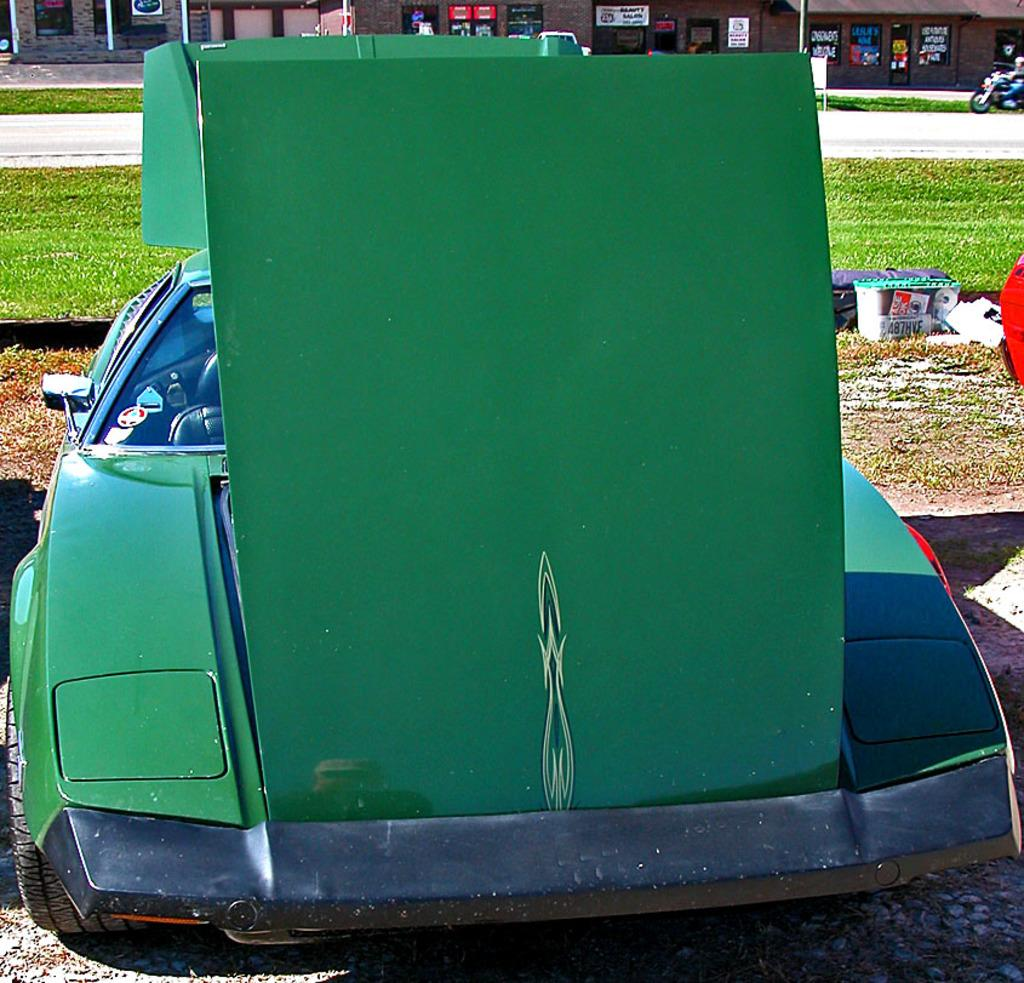What color is the vehicle in the image? The vehicle in the image is green. What type of vegetation can be seen in the image? There is grass visible in the image. What is covering the object in the image? There is a cover in the image. Can you describe the background of the image? In the background of the image, there is a road, a motorbike, houses, and poles. What type of pet can be seen in the image? There is no pet present in the image. What type of alarm is going off in the image? There is no alarm present in the image. 